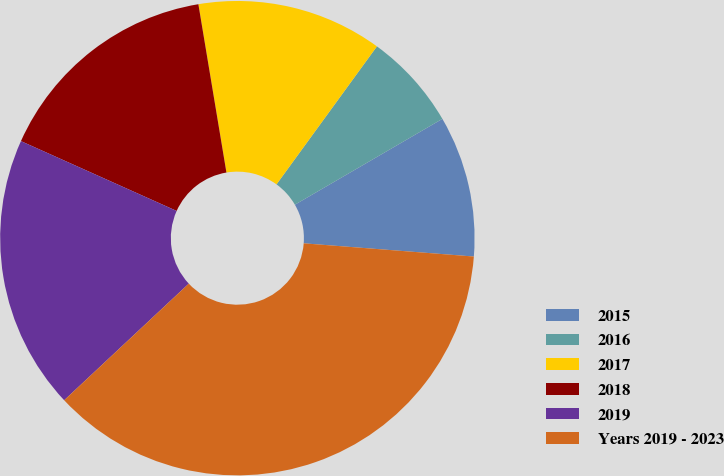<chart> <loc_0><loc_0><loc_500><loc_500><pie_chart><fcel>2015<fcel>2016<fcel>2017<fcel>2018<fcel>2019<fcel>Years 2019 - 2023<nl><fcel>9.62%<fcel>6.6%<fcel>12.64%<fcel>15.66%<fcel>18.68%<fcel>36.79%<nl></chart> 